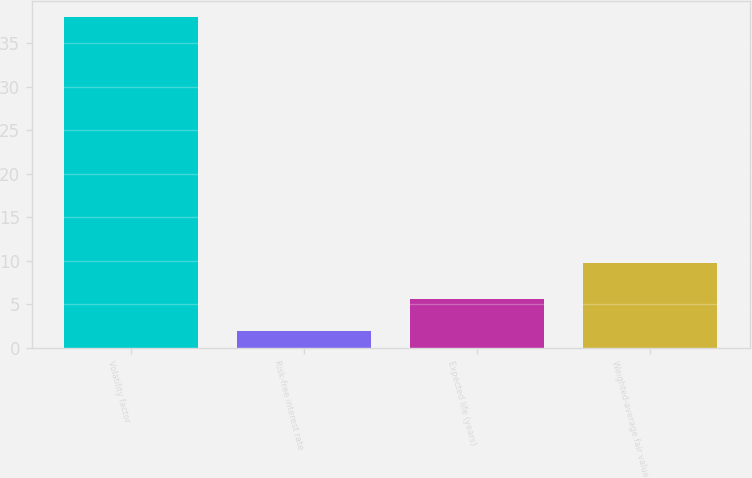Convert chart. <chart><loc_0><loc_0><loc_500><loc_500><bar_chart><fcel>Volatility factor<fcel>Risk-free interest rate<fcel>Expected life (years)<fcel>Weighted-average fair value<nl><fcel>38<fcel>2<fcel>5.6<fcel>9.77<nl></chart> 